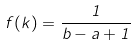Convert formula to latex. <formula><loc_0><loc_0><loc_500><loc_500>f ( k ) = \frac { 1 } { b - a + 1 }</formula> 